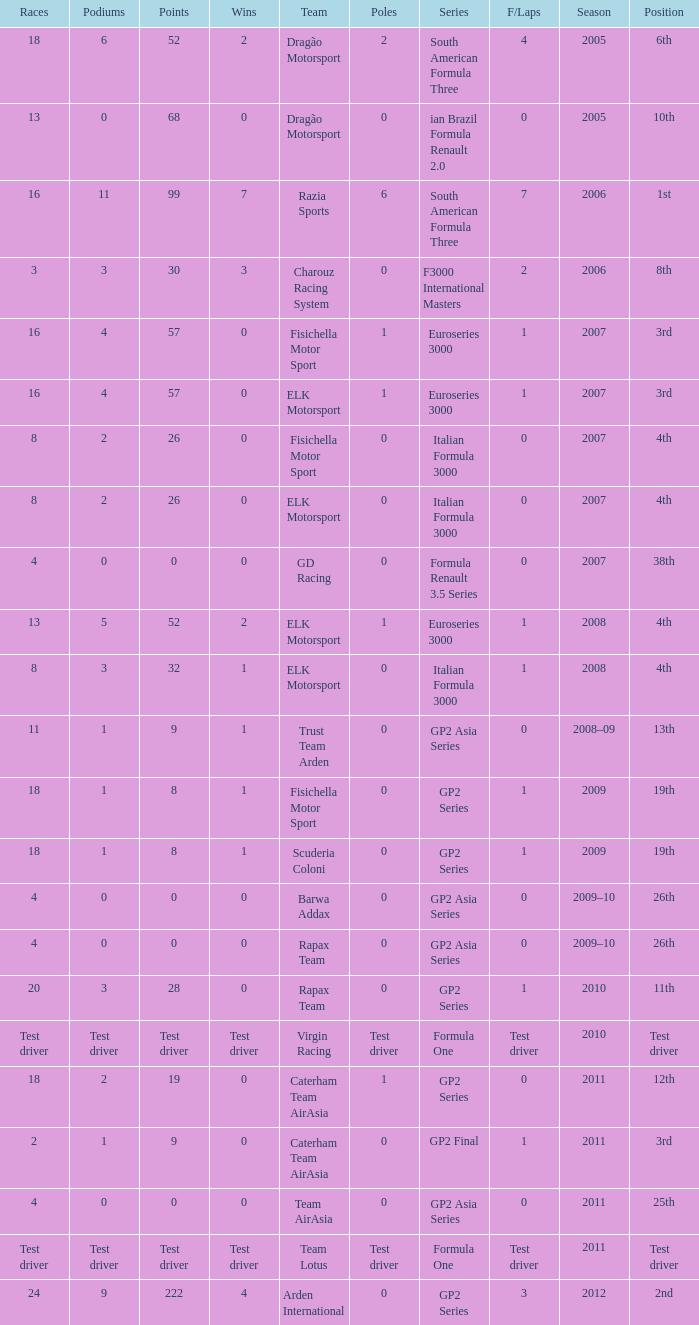How many races did he do in the year he had 8 points? 18, 18. 